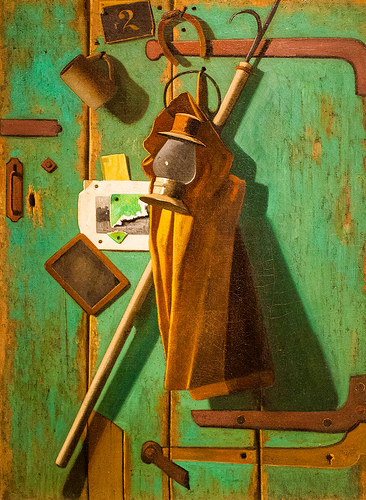<image>
Can you confirm if the lamp is in the coat? No. The lamp is not contained within the coat. These objects have a different spatial relationship. 